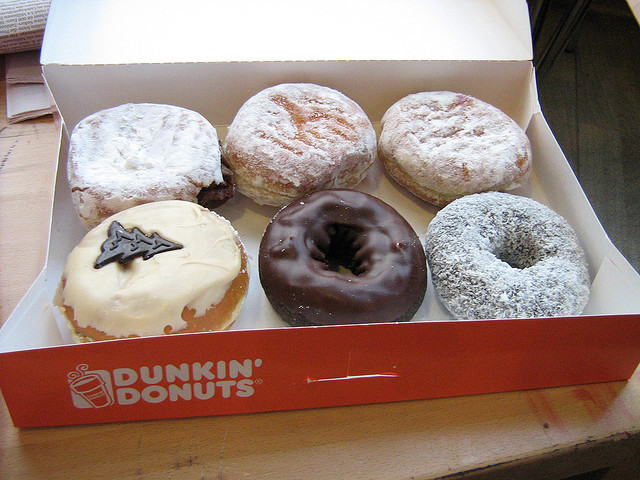<image>What has the box been written? I am not sure what has been written on the box. It could be 'dunkin donuts'. What has the box been written? I don't know what has been written on the box. It can be seen 'dunkin' donuts' or 'none'. 